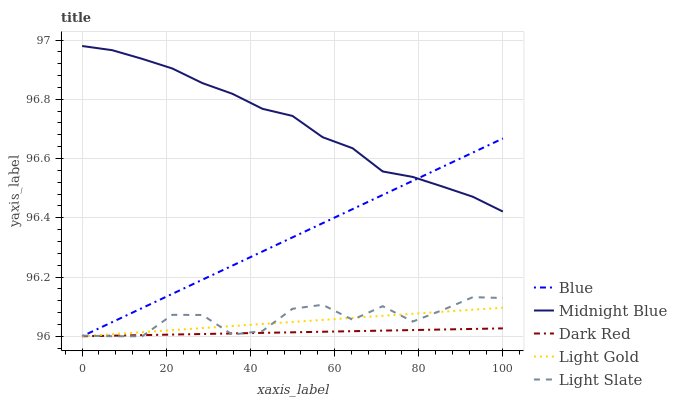Does Dark Red have the minimum area under the curve?
Answer yes or no. Yes. Does Midnight Blue have the maximum area under the curve?
Answer yes or no. Yes. Does Light Gold have the minimum area under the curve?
Answer yes or no. No. Does Light Gold have the maximum area under the curve?
Answer yes or no. No. Is Light Gold the smoothest?
Answer yes or no. Yes. Is Light Slate the roughest?
Answer yes or no. Yes. Is Dark Red the smoothest?
Answer yes or no. No. Is Dark Red the roughest?
Answer yes or no. No. Does Blue have the lowest value?
Answer yes or no. Yes. Does Midnight Blue have the lowest value?
Answer yes or no. No. Does Midnight Blue have the highest value?
Answer yes or no. Yes. Does Light Gold have the highest value?
Answer yes or no. No. Is Light Gold less than Midnight Blue?
Answer yes or no. Yes. Is Midnight Blue greater than Light Gold?
Answer yes or no. Yes. Does Blue intersect Midnight Blue?
Answer yes or no. Yes. Is Blue less than Midnight Blue?
Answer yes or no. No. Is Blue greater than Midnight Blue?
Answer yes or no. No. Does Light Gold intersect Midnight Blue?
Answer yes or no. No. 